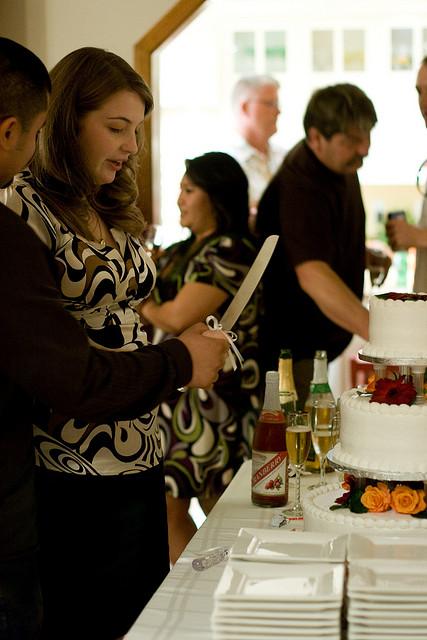How many layer on this cake?
Quick response, please. 2. How many bottles are on table?
Give a very brief answer. 3. Are two people wearing similar patterns?
Give a very brief answer. Yes. 